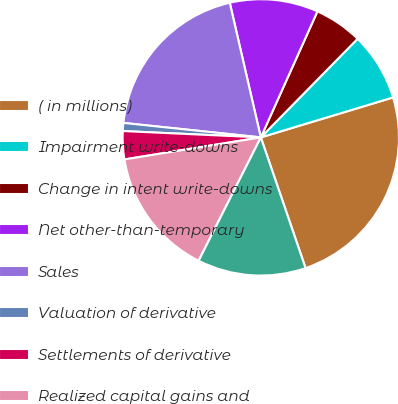<chart> <loc_0><loc_0><loc_500><loc_500><pie_chart><fcel>( in millions)<fcel>Impairment write-downs<fcel>Change in intent write-downs<fcel>Net other-than-temporary<fcel>Sales<fcel>Valuation of derivative<fcel>Settlements of derivative<fcel>Realized capital gains and<fcel>Income tax (expense) benefit<nl><fcel>24.42%<fcel>7.98%<fcel>5.63%<fcel>10.33%<fcel>19.72%<fcel>0.94%<fcel>3.28%<fcel>15.02%<fcel>12.68%<nl></chart> 